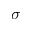<formula> <loc_0><loc_0><loc_500><loc_500>\sigma</formula> 